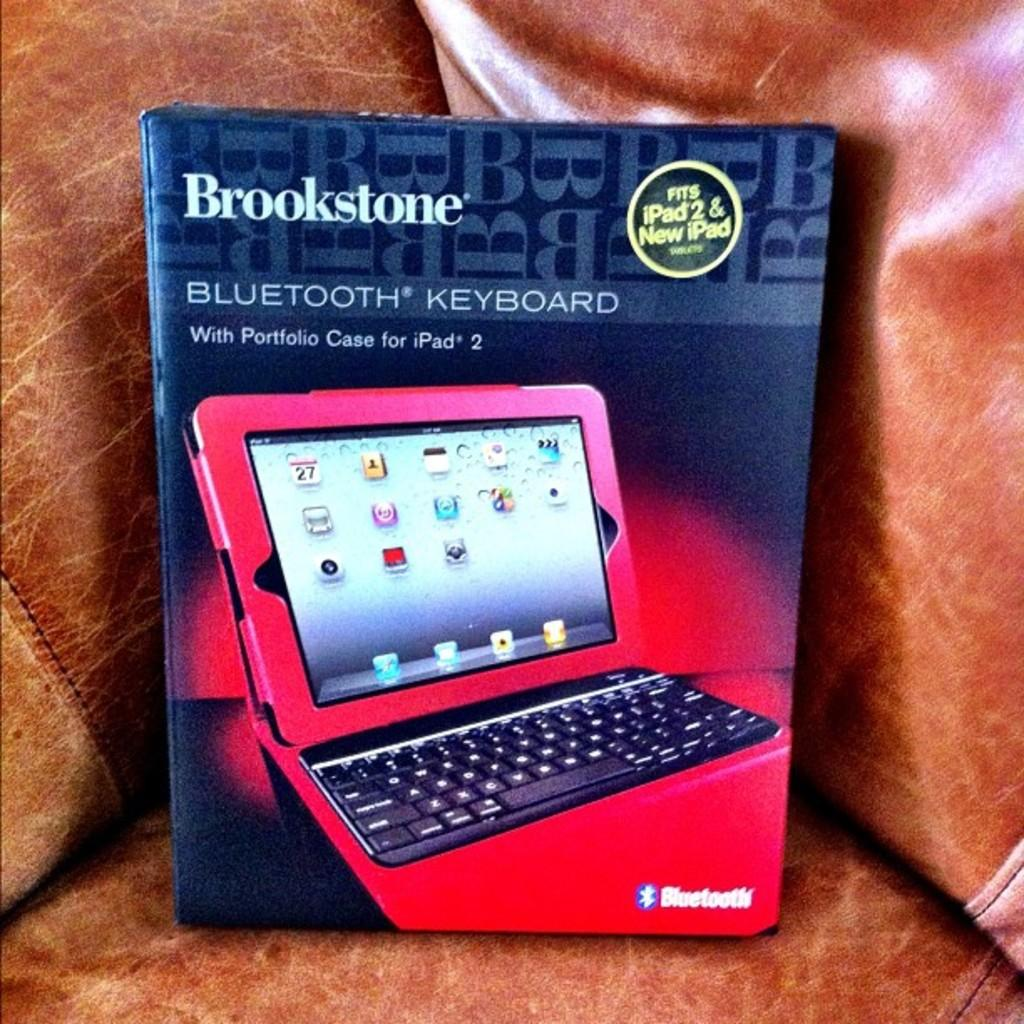What is located at the front of the image? There is a box in the front of the image. What is depicted on the box? There is a picture of a laptop on the box. What else can be seen on the box besides the image? There is text present on the box. What type of furniture is visible at the bottom of the image? It appears that there is a sofa at the bottom of the image. What type of watch is the person wearing in the image? There is no person wearing a watch in the image; it only features a box with a laptop image and a sofa at the bottom. 